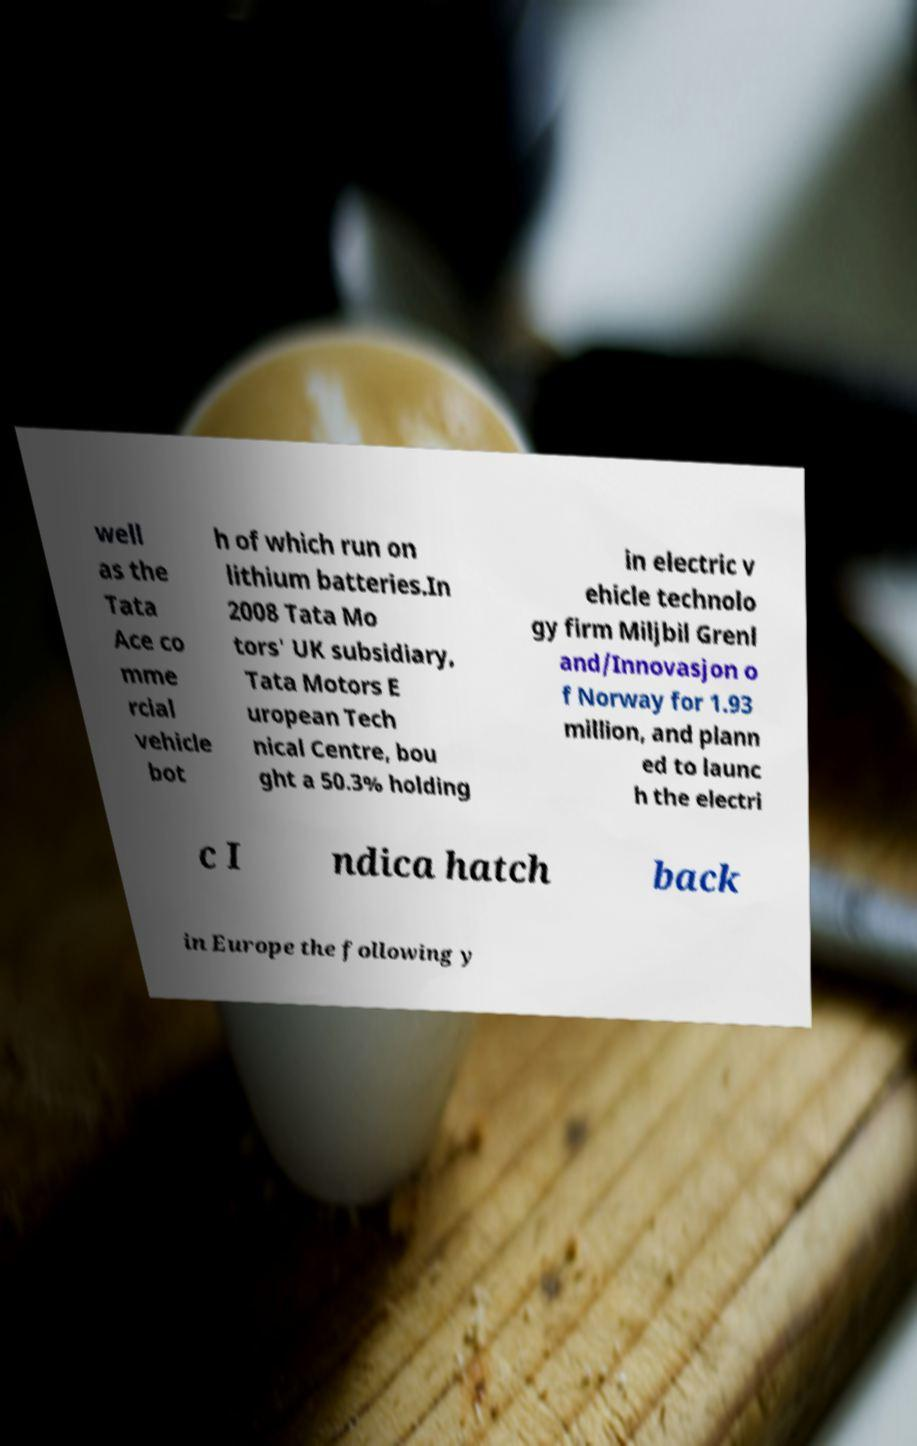Could you assist in decoding the text presented in this image and type it out clearly? well as the Tata Ace co mme rcial vehicle bot h of which run on lithium batteries.In 2008 Tata Mo tors' UK subsidiary, Tata Motors E uropean Tech nical Centre, bou ght a 50.3% holding in electric v ehicle technolo gy firm Miljbil Grenl and/Innovasjon o f Norway for 1.93 million, and plann ed to launc h the electri c I ndica hatch back in Europe the following y 